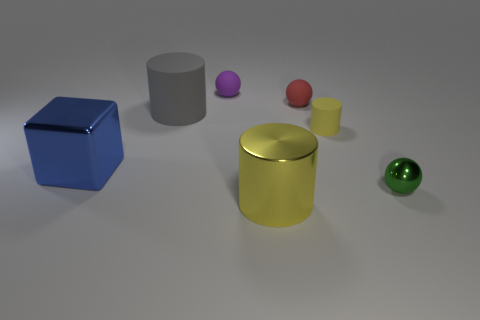Do the metal object that is to the left of the purple rubber thing and the yellow matte object have the same size?
Make the answer very short. No. What number of small yellow matte things are in front of the big blue block?
Provide a succinct answer. 0. Are there any red rubber things that have the same size as the green object?
Your response must be concise. Yes. Is the tiny cylinder the same color as the shiny cylinder?
Provide a short and direct response. Yes. There is a cylinder that is left of the big yellow cylinder that is in front of the large gray rubber cylinder; what is its color?
Ensure brevity in your answer.  Gray. How many objects are both in front of the tiny rubber cylinder and on the right side of the red matte object?
Make the answer very short. 1. How many red objects are the same shape as the small yellow thing?
Provide a short and direct response. 0. Does the small green object have the same material as the purple ball?
Give a very brief answer. No. What shape is the tiny object behind the tiny matte ball that is in front of the purple rubber sphere?
Offer a very short reply. Sphere. What number of big blue objects are to the right of the rubber cylinder that is to the right of the red object?
Offer a very short reply. 0. 